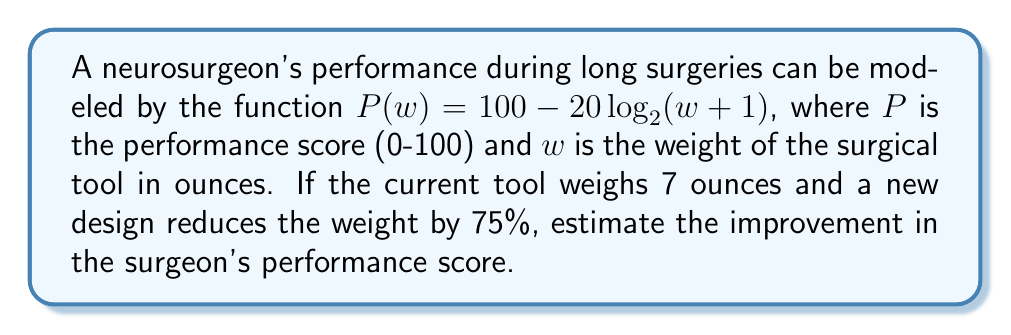Can you solve this math problem? 1) First, let's calculate the current performance score with the 7-ounce tool:
   $P(7) = 100 - 20\log_2(7+1) = 100 - 20\log_2(8) = 100 - 20(3) = 100 - 60 = 40$

2) Now, let's calculate the weight of the new tool:
   New weight = 7 - (75% of 7) = 7 - (0.75 * 7) = 7 - 5.25 = 1.75 ounces

3) Calculate the performance score with the new tool:
   $P(1.75) = 100 - 20\log_2(1.75+1) = 100 - 20\log_2(2.75)$
   $= 100 - 20(1.4594) = 100 - 29.188 = 70.812$

4) Calculate the improvement:
   Improvement = New score - Old score
   $= 70.812 - 40 = 30.812$
Answer: 30.812 